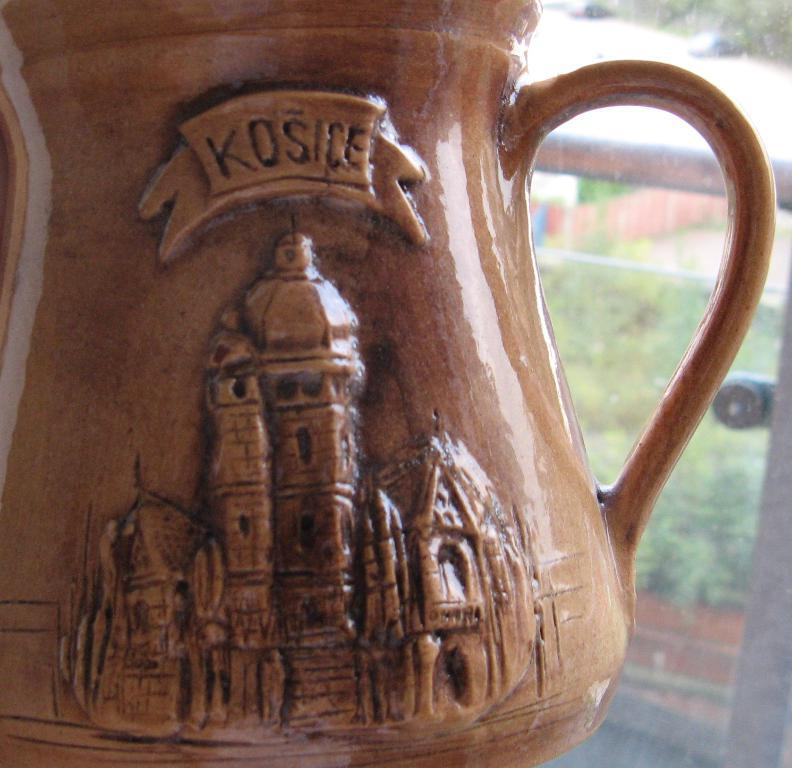What object is present in the image? There is a mug in the image. What material is the mug made of? The mug is made of ceramic. What color is the mug? The mug is brown in color. What can be seen in the background of the image? There is a window in the background of the image. What type of rice is being cooked in the mug in the image? There is no rice present in the image; it only features a brown ceramic mug. 